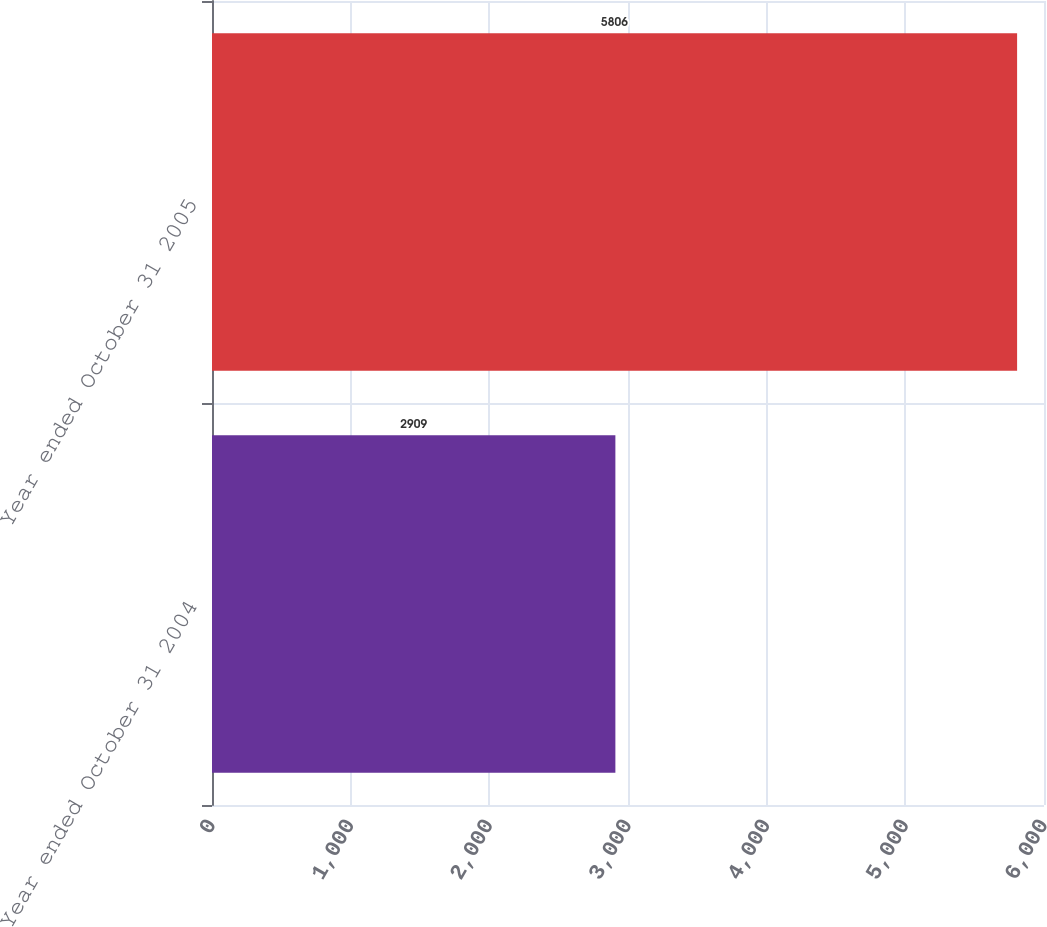<chart> <loc_0><loc_0><loc_500><loc_500><bar_chart><fcel>Year ended October 31 2004<fcel>Year ended October 31 2005<nl><fcel>2909<fcel>5806<nl></chart> 